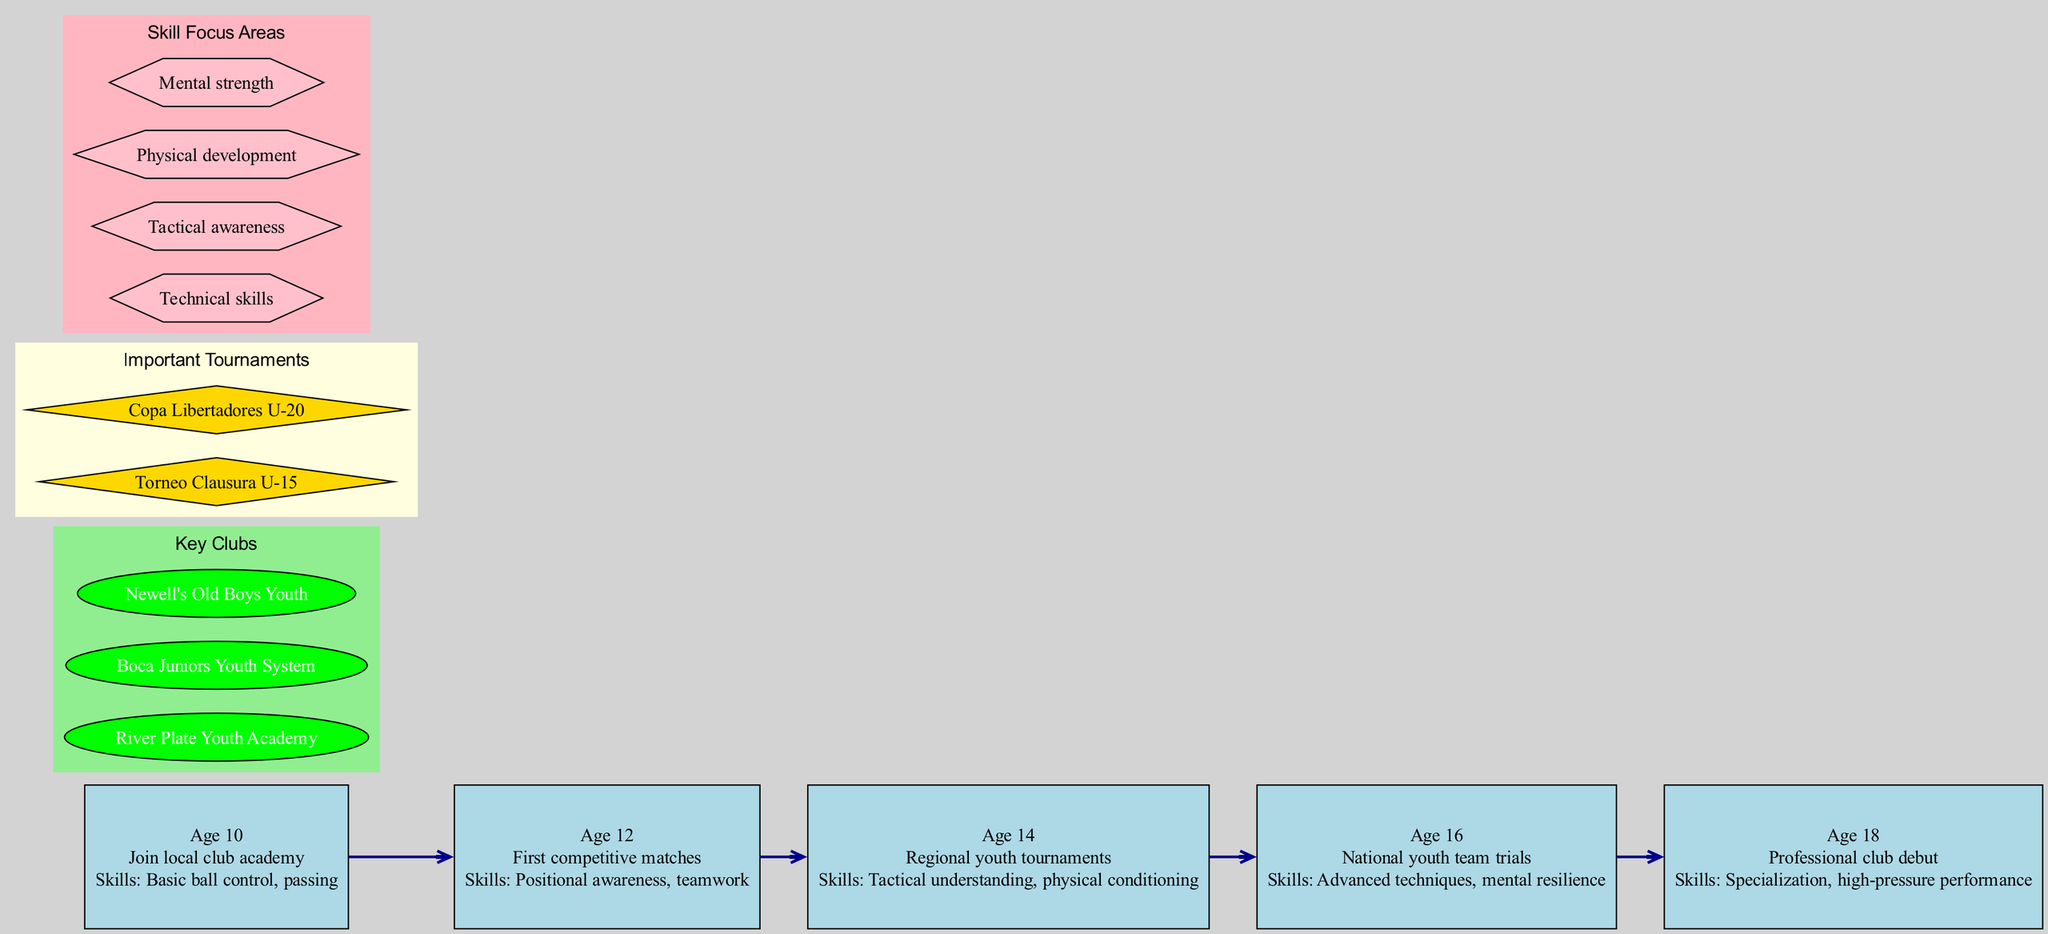What is the milestone at age 10? The diagram specifies that at age 10, the milestone is "Join local club academy." This was directly indicated under the age 10 node in the timeline section of the diagram.
Answer: Join local club academy How many key clubs are listed in the diagram? The diagram shows three key clubs listed. This can be counted from the section labeled "Key Clubs," which contains three distinct entries.
Answer: 3 What skill is focused on at age 16? The diagram indicates that at age 16, the skills focused on are "Advanced techniques, mental resilience." This information is provided under the age 16 node in the timeline section.
Answer: Advanced techniques, mental resilience Which tournament is highlighted for U-15 players? The diagram mentions "Torneo Clausura U-15" as the important tournament for U-15 players. This tournament appears in the section labeled "Important Tournaments."
Answer: Torneo Clausura U-15 What age marks the transition to professional club debut? According to the timeline, the transition to professional club debut occurs at age 18. This information is found at the final milestone in the timeline.
Answer: 18 Which skill focus area is related to physical development? The diagram lists "Physical development" as one of the skill focus areas. This can be observed in the section titled "Skill Focus Areas."
Answer: Physical development What is the first milestone on the timeline? The first milestone on the timeline, represented at age 10, is "Join local club academy." This is directly stated next to the age 10 node.
Answer: Join local club academy At which age do players experience their first competitive matches? The diagram specifies that players experience their first competitive matches at age 12. This is indicated under the age 12 milestone in the timeline.
Answer: 12 What color represents key clubs in the diagram? The key clubs in the diagram are represented with the color green. This is indicated in the color attribute of the subgraph for key clubs.
Answer: Green 